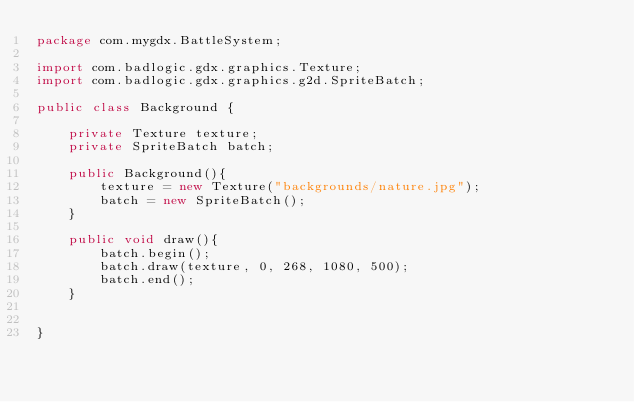<code> <loc_0><loc_0><loc_500><loc_500><_Java_>package com.mygdx.BattleSystem;

import com.badlogic.gdx.graphics.Texture;
import com.badlogic.gdx.graphics.g2d.SpriteBatch;

public class Background {

    private Texture texture;
    private SpriteBatch batch;

    public Background(){
        texture = new Texture("backgrounds/nature.jpg");
        batch = new SpriteBatch();
    }

    public void draw(){
        batch.begin();
        batch.draw(texture, 0, 268, 1080, 500);
        batch.end();
    }


}
</code> 